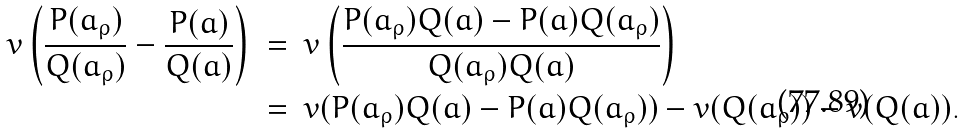<formula> <loc_0><loc_0><loc_500><loc_500>v \left ( \frac { P ( a _ { \rho } ) } { Q ( a _ { \rho } ) } - \frac { P ( a ) } { Q ( a ) } \right ) \ & = \ v \left ( \frac { P ( a _ { \rho } ) Q ( a ) - P ( a ) Q ( a _ { \rho } ) } { Q ( a _ { \rho } ) Q ( a ) } \right ) \\ & = \ v ( P ( a _ { \rho } ) Q ( a ) - P ( a ) Q ( a _ { \rho } ) ) - v ( Q ( a _ { \rho } ) ) - v ( Q ( a ) ) .</formula> 